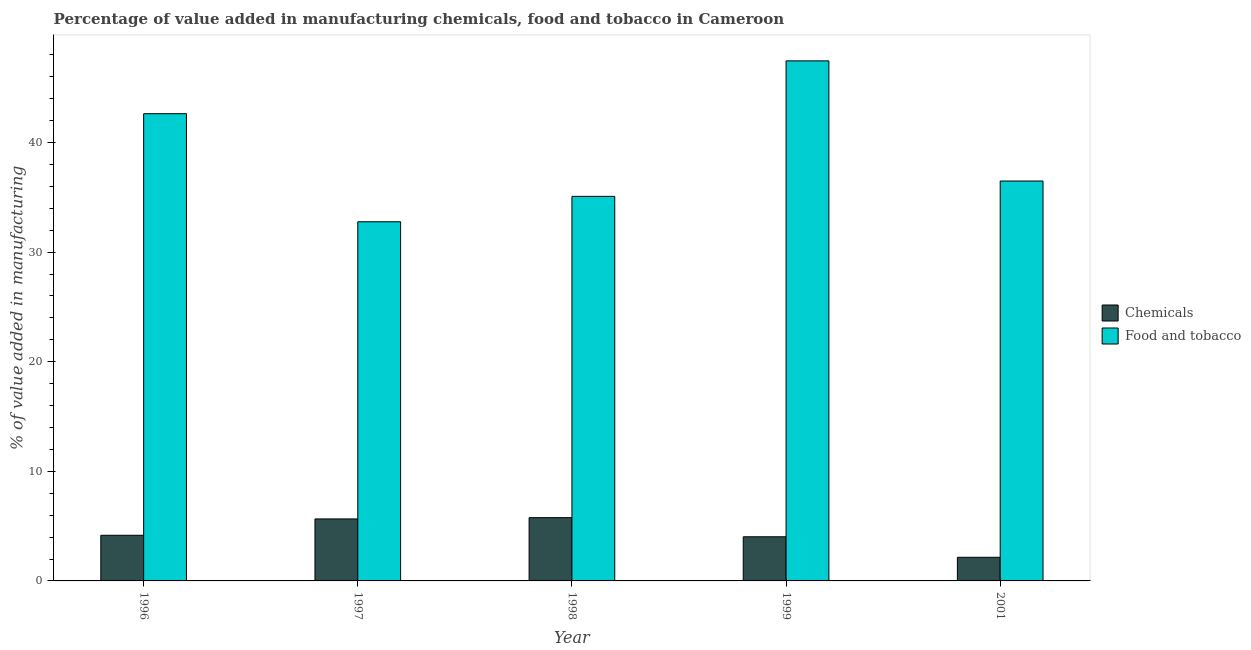How many different coloured bars are there?
Make the answer very short. 2. Are the number of bars per tick equal to the number of legend labels?
Your response must be concise. Yes. What is the label of the 3rd group of bars from the left?
Ensure brevity in your answer.  1998. In how many cases, is the number of bars for a given year not equal to the number of legend labels?
Give a very brief answer. 0. What is the value added by manufacturing food and tobacco in 1999?
Provide a short and direct response. 47.46. Across all years, what is the maximum value added by manufacturing food and tobacco?
Offer a terse response. 47.46. Across all years, what is the minimum value added by  manufacturing chemicals?
Offer a very short reply. 2.16. In which year was the value added by  manufacturing chemicals maximum?
Provide a succinct answer. 1998. What is the total value added by manufacturing food and tobacco in the graph?
Your response must be concise. 194.45. What is the difference between the value added by manufacturing food and tobacco in 1998 and that in 2001?
Your answer should be compact. -1.4. What is the difference between the value added by  manufacturing chemicals in 1997 and the value added by manufacturing food and tobacco in 2001?
Provide a succinct answer. 3.5. What is the average value added by  manufacturing chemicals per year?
Make the answer very short. 4.36. In how many years, is the value added by  manufacturing chemicals greater than 46 %?
Provide a succinct answer. 0. What is the ratio of the value added by manufacturing food and tobacco in 1999 to that in 2001?
Keep it short and to the point. 1.3. Is the value added by manufacturing food and tobacco in 1996 less than that in 2001?
Your answer should be very brief. No. Is the difference between the value added by manufacturing food and tobacco in 1998 and 1999 greater than the difference between the value added by  manufacturing chemicals in 1998 and 1999?
Ensure brevity in your answer.  No. What is the difference between the highest and the second highest value added by manufacturing food and tobacco?
Your answer should be very brief. 4.82. What is the difference between the highest and the lowest value added by  manufacturing chemicals?
Provide a succinct answer. 3.62. In how many years, is the value added by  manufacturing chemicals greater than the average value added by  manufacturing chemicals taken over all years?
Offer a very short reply. 2. What does the 2nd bar from the left in 1996 represents?
Ensure brevity in your answer.  Food and tobacco. What does the 1st bar from the right in 1997 represents?
Your response must be concise. Food and tobacco. How many bars are there?
Make the answer very short. 10. Are all the bars in the graph horizontal?
Your answer should be very brief. No. How many years are there in the graph?
Your answer should be compact. 5. What is the difference between two consecutive major ticks on the Y-axis?
Provide a short and direct response. 10. Does the graph contain any zero values?
Offer a very short reply. No. Does the graph contain grids?
Offer a very short reply. No. Where does the legend appear in the graph?
Make the answer very short. Center right. How many legend labels are there?
Offer a terse response. 2. How are the legend labels stacked?
Offer a very short reply. Vertical. What is the title of the graph?
Provide a short and direct response. Percentage of value added in manufacturing chemicals, food and tobacco in Cameroon. What is the label or title of the X-axis?
Provide a succinct answer. Year. What is the label or title of the Y-axis?
Keep it short and to the point. % of value added in manufacturing. What is the % of value added in manufacturing of Chemicals in 1996?
Make the answer very short. 4.17. What is the % of value added in manufacturing in Food and tobacco in 1996?
Your answer should be compact. 42.63. What is the % of value added in manufacturing in Chemicals in 1997?
Keep it short and to the point. 5.66. What is the % of value added in manufacturing of Food and tobacco in 1997?
Keep it short and to the point. 32.77. What is the % of value added in manufacturing of Chemicals in 1998?
Your answer should be compact. 5.77. What is the % of value added in manufacturing of Food and tobacco in 1998?
Make the answer very short. 35.09. What is the % of value added in manufacturing of Chemicals in 1999?
Offer a very short reply. 4.03. What is the % of value added in manufacturing in Food and tobacco in 1999?
Offer a terse response. 47.46. What is the % of value added in manufacturing of Chemicals in 2001?
Make the answer very short. 2.16. What is the % of value added in manufacturing of Food and tobacco in 2001?
Ensure brevity in your answer.  36.49. Across all years, what is the maximum % of value added in manufacturing of Chemicals?
Give a very brief answer. 5.77. Across all years, what is the maximum % of value added in manufacturing of Food and tobacco?
Make the answer very short. 47.46. Across all years, what is the minimum % of value added in manufacturing in Chemicals?
Keep it short and to the point. 2.16. Across all years, what is the minimum % of value added in manufacturing in Food and tobacco?
Ensure brevity in your answer.  32.77. What is the total % of value added in manufacturing of Chemicals in the graph?
Provide a succinct answer. 21.78. What is the total % of value added in manufacturing in Food and tobacco in the graph?
Make the answer very short. 194.45. What is the difference between the % of value added in manufacturing in Chemicals in 1996 and that in 1997?
Your answer should be very brief. -1.49. What is the difference between the % of value added in manufacturing in Food and tobacco in 1996 and that in 1997?
Provide a succinct answer. 9.86. What is the difference between the % of value added in manufacturing in Chemicals in 1996 and that in 1998?
Give a very brief answer. -1.61. What is the difference between the % of value added in manufacturing in Food and tobacco in 1996 and that in 1998?
Make the answer very short. 7.54. What is the difference between the % of value added in manufacturing of Chemicals in 1996 and that in 1999?
Offer a terse response. 0.14. What is the difference between the % of value added in manufacturing of Food and tobacco in 1996 and that in 1999?
Provide a short and direct response. -4.82. What is the difference between the % of value added in manufacturing of Chemicals in 1996 and that in 2001?
Ensure brevity in your answer.  2.01. What is the difference between the % of value added in manufacturing in Food and tobacco in 1996 and that in 2001?
Provide a succinct answer. 6.14. What is the difference between the % of value added in manufacturing of Chemicals in 1997 and that in 1998?
Your answer should be very brief. -0.12. What is the difference between the % of value added in manufacturing in Food and tobacco in 1997 and that in 1998?
Ensure brevity in your answer.  -2.32. What is the difference between the % of value added in manufacturing of Chemicals in 1997 and that in 1999?
Make the answer very short. 1.63. What is the difference between the % of value added in manufacturing in Food and tobacco in 1997 and that in 1999?
Your answer should be very brief. -14.68. What is the difference between the % of value added in manufacturing of Chemicals in 1997 and that in 2001?
Ensure brevity in your answer.  3.5. What is the difference between the % of value added in manufacturing in Food and tobacco in 1997 and that in 2001?
Ensure brevity in your answer.  -3.72. What is the difference between the % of value added in manufacturing in Chemicals in 1998 and that in 1999?
Provide a short and direct response. 1.75. What is the difference between the % of value added in manufacturing of Food and tobacco in 1998 and that in 1999?
Keep it short and to the point. -12.36. What is the difference between the % of value added in manufacturing of Chemicals in 1998 and that in 2001?
Your response must be concise. 3.62. What is the difference between the % of value added in manufacturing of Chemicals in 1999 and that in 2001?
Provide a short and direct response. 1.87. What is the difference between the % of value added in manufacturing of Food and tobacco in 1999 and that in 2001?
Ensure brevity in your answer.  10.96. What is the difference between the % of value added in manufacturing of Chemicals in 1996 and the % of value added in manufacturing of Food and tobacco in 1997?
Make the answer very short. -28.61. What is the difference between the % of value added in manufacturing of Chemicals in 1996 and the % of value added in manufacturing of Food and tobacco in 1998?
Your response must be concise. -30.93. What is the difference between the % of value added in manufacturing of Chemicals in 1996 and the % of value added in manufacturing of Food and tobacco in 1999?
Provide a succinct answer. -43.29. What is the difference between the % of value added in manufacturing in Chemicals in 1996 and the % of value added in manufacturing in Food and tobacco in 2001?
Give a very brief answer. -32.33. What is the difference between the % of value added in manufacturing in Chemicals in 1997 and the % of value added in manufacturing in Food and tobacco in 1998?
Your answer should be very brief. -29.43. What is the difference between the % of value added in manufacturing in Chemicals in 1997 and the % of value added in manufacturing in Food and tobacco in 1999?
Ensure brevity in your answer.  -41.8. What is the difference between the % of value added in manufacturing in Chemicals in 1997 and the % of value added in manufacturing in Food and tobacco in 2001?
Give a very brief answer. -30.83. What is the difference between the % of value added in manufacturing in Chemicals in 1998 and the % of value added in manufacturing in Food and tobacco in 1999?
Your answer should be compact. -41.68. What is the difference between the % of value added in manufacturing of Chemicals in 1998 and the % of value added in manufacturing of Food and tobacco in 2001?
Provide a short and direct response. -30.72. What is the difference between the % of value added in manufacturing of Chemicals in 1999 and the % of value added in manufacturing of Food and tobacco in 2001?
Your response must be concise. -32.46. What is the average % of value added in manufacturing of Chemicals per year?
Your answer should be very brief. 4.36. What is the average % of value added in manufacturing of Food and tobacco per year?
Your response must be concise. 38.89. In the year 1996, what is the difference between the % of value added in manufacturing of Chemicals and % of value added in manufacturing of Food and tobacco?
Provide a short and direct response. -38.47. In the year 1997, what is the difference between the % of value added in manufacturing of Chemicals and % of value added in manufacturing of Food and tobacco?
Your answer should be very brief. -27.12. In the year 1998, what is the difference between the % of value added in manufacturing of Chemicals and % of value added in manufacturing of Food and tobacco?
Your answer should be very brief. -29.32. In the year 1999, what is the difference between the % of value added in manufacturing of Chemicals and % of value added in manufacturing of Food and tobacco?
Offer a terse response. -43.43. In the year 2001, what is the difference between the % of value added in manufacturing in Chemicals and % of value added in manufacturing in Food and tobacco?
Provide a succinct answer. -34.34. What is the ratio of the % of value added in manufacturing in Chemicals in 1996 to that in 1997?
Offer a terse response. 0.74. What is the ratio of the % of value added in manufacturing of Food and tobacco in 1996 to that in 1997?
Your response must be concise. 1.3. What is the ratio of the % of value added in manufacturing of Chemicals in 1996 to that in 1998?
Provide a short and direct response. 0.72. What is the ratio of the % of value added in manufacturing in Food and tobacco in 1996 to that in 1998?
Your response must be concise. 1.21. What is the ratio of the % of value added in manufacturing of Chemicals in 1996 to that in 1999?
Your response must be concise. 1.03. What is the ratio of the % of value added in manufacturing in Food and tobacco in 1996 to that in 1999?
Offer a terse response. 0.9. What is the ratio of the % of value added in manufacturing of Chemicals in 1996 to that in 2001?
Ensure brevity in your answer.  1.93. What is the ratio of the % of value added in manufacturing in Food and tobacco in 1996 to that in 2001?
Your answer should be very brief. 1.17. What is the ratio of the % of value added in manufacturing of Chemicals in 1997 to that in 1998?
Your answer should be very brief. 0.98. What is the ratio of the % of value added in manufacturing in Food and tobacco in 1997 to that in 1998?
Offer a very short reply. 0.93. What is the ratio of the % of value added in manufacturing of Chemicals in 1997 to that in 1999?
Your answer should be compact. 1.4. What is the ratio of the % of value added in manufacturing of Food and tobacco in 1997 to that in 1999?
Offer a terse response. 0.69. What is the ratio of the % of value added in manufacturing in Chemicals in 1997 to that in 2001?
Your answer should be compact. 2.62. What is the ratio of the % of value added in manufacturing of Food and tobacco in 1997 to that in 2001?
Keep it short and to the point. 0.9. What is the ratio of the % of value added in manufacturing of Chemicals in 1998 to that in 1999?
Make the answer very short. 1.43. What is the ratio of the % of value added in manufacturing in Food and tobacco in 1998 to that in 1999?
Offer a very short reply. 0.74. What is the ratio of the % of value added in manufacturing of Chemicals in 1998 to that in 2001?
Keep it short and to the point. 2.68. What is the ratio of the % of value added in manufacturing in Food and tobacco in 1998 to that in 2001?
Offer a very short reply. 0.96. What is the ratio of the % of value added in manufacturing of Chemicals in 1999 to that in 2001?
Your response must be concise. 1.87. What is the ratio of the % of value added in manufacturing in Food and tobacco in 1999 to that in 2001?
Give a very brief answer. 1.3. What is the difference between the highest and the second highest % of value added in manufacturing of Chemicals?
Give a very brief answer. 0.12. What is the difference between the highest and the second highest % of value added in manufacturing in Food and tobacco?
Your answer should be compact. 4.82. What is the difference between the highest and the lowest % of value added in manufacturing in Chemicals?
Your response must be concise. 3.62. What is the difference between the highest and the lowest % of value added in manufacturing in Food and tobacco?
Give a very brief answer. 14.68. 